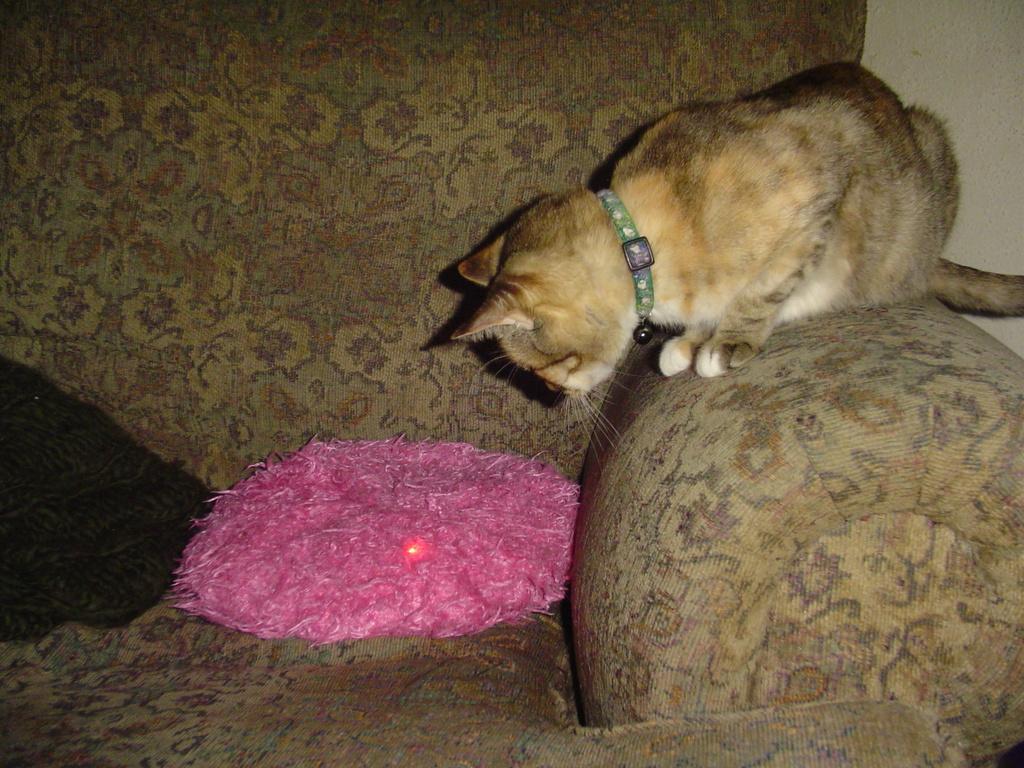Could you give a brief overview of what you see in this image? In this image I can see an animal which is in brown and white color. I can see an animal is on the couch. To the side I can see the pink and black color objects on the couch. 